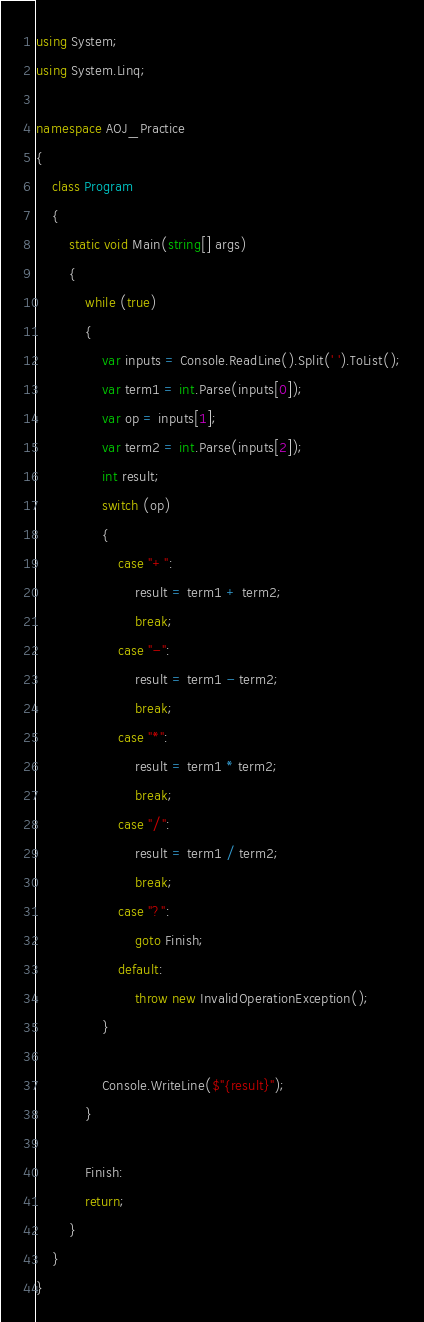<code> <loc_0><loc_0><loc_500><loc_500><_C#_>using System;
using System.Linq;

namespace AOJ_Practice
{
    class Program
    {
        static void Main(string[] args)
        {
            while (true)
            {
                var inputs = Console.ReadLine().Split(' ').ToList();
                var term1 = int.Parse(inputs[0]);
                var op = inputs[1];
                var term2 = int.Parse(inputs[2]);
                int result;
                switch (op)
                {
                    case "+":
                        result = term1 + term2;
                        break;
                    case "-":
                        result = term1 - term2;
                        break;
                    case "*":
                        result = term1 * term2;
                        break;
                    case "/":
                        result = term1 / term2;
                        break;
                    case "?":
                        goto Finish;
                    default:
                        throw new InvalidOperationException();
                }

                Console.WriteLine($"{result}");
            }

            Finish:
            return;
        }
    }
}

</code> 